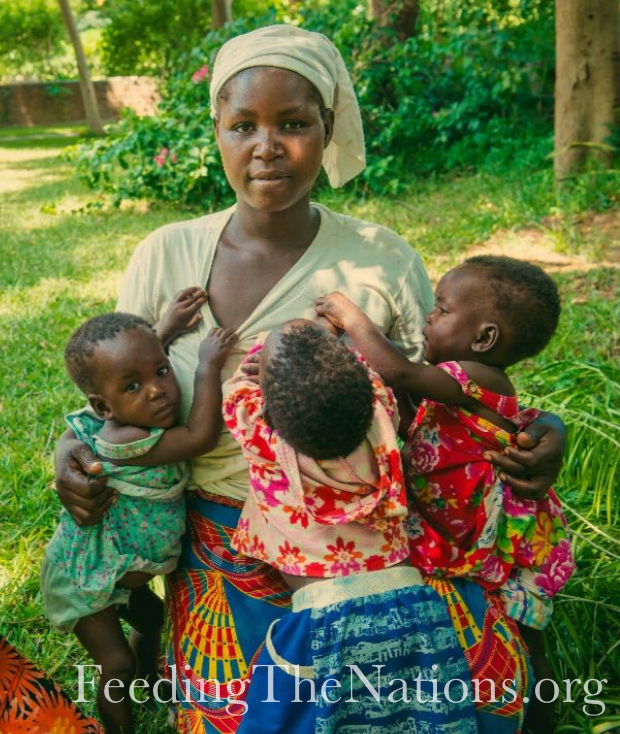Tell me more about the significance of the clothing worn by the woman and the children. The clothing worn by the woman and the children in the image features bright, colorful patterns typical of many African cultures, particularly those in East and West Africa. This style of dress is often handmade, using traditional fabrics like 'ankara,' known for its vibrant colors and intricate patterns. Such clothing is not only practical in warmer climates but also holds cultural significance, often representing different tribal identities, social statuses, or ceremonial purposes. The coordinated style and colors among the group suggest a close connection, possibly indicating family ties or cultural unity within a community. 